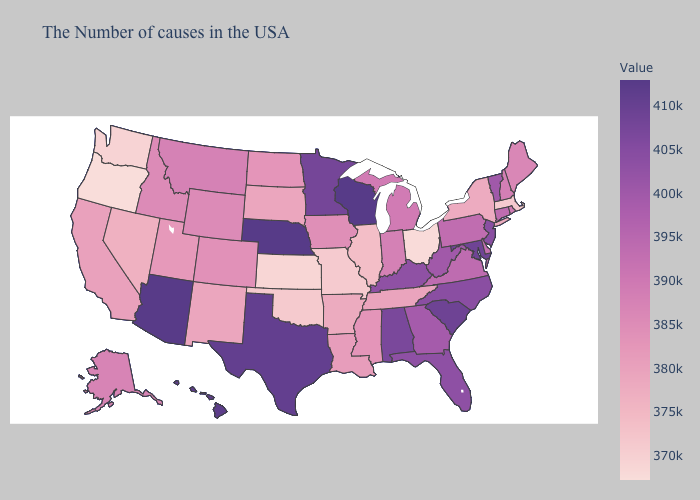Does Missouri have a higher value than South Dakota?
Concise answer only. No. Does Washington have the highest value in the West?
Answer briefly. No. Does Oregon have the lowest value in the USA?
Concise answer only. Yes. Does Colorado have a higher value than Illinois?
Write a very short answer. Yes. Which states hav the highest value in the MidWest?
Short answer required. Nebraska. 